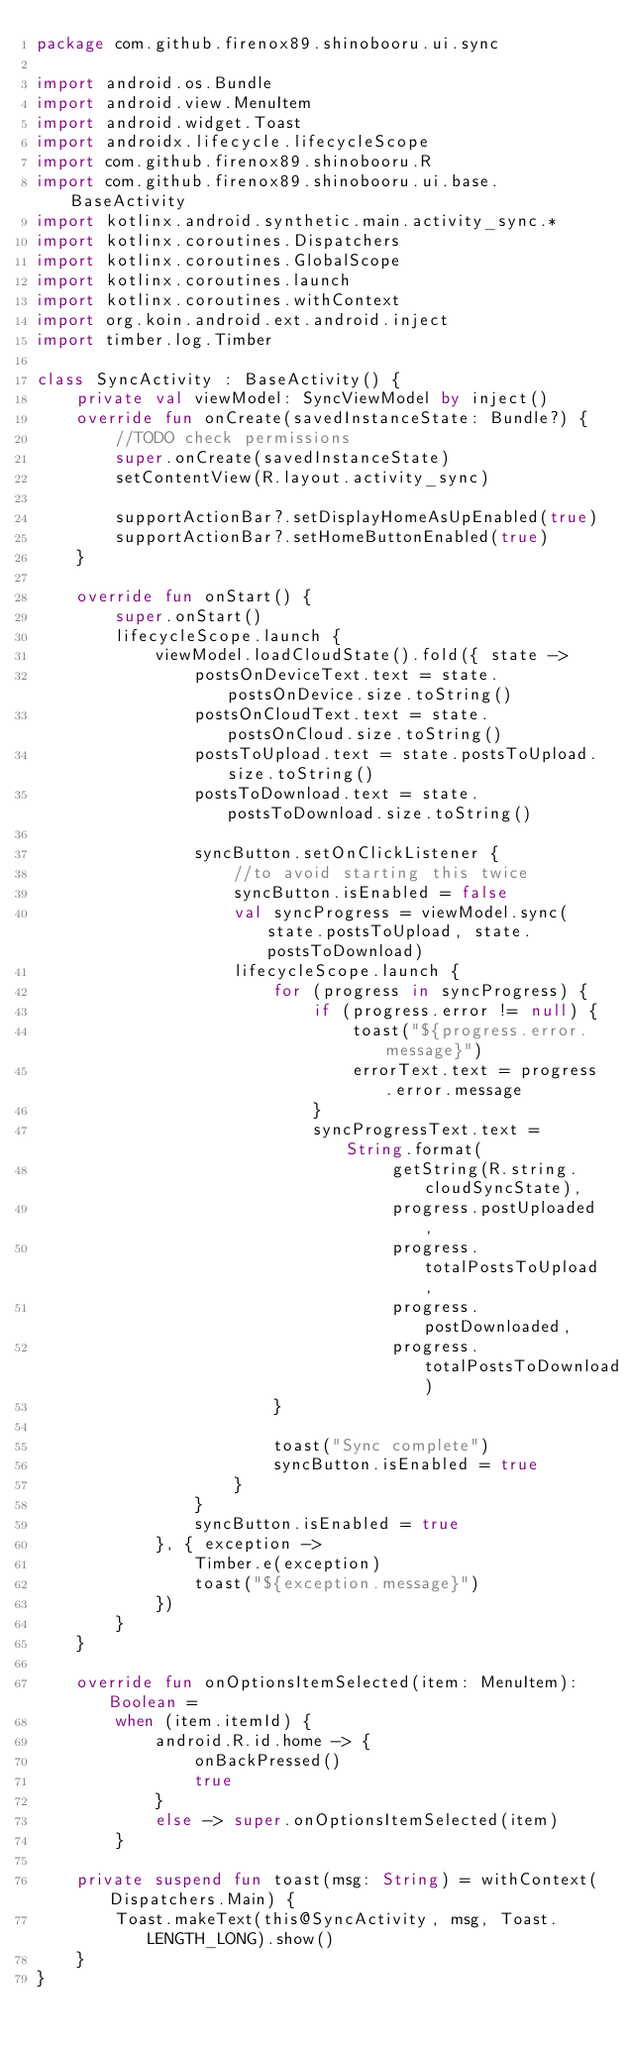<code> <loc_0><loc_0><loc_500><loc_500><_Kotlin_>package com.github.firenox89.shinobooru.ui.sync

import android.os.Bundle
import android.view.MenuItem
import android.widget.Toast
import androidx.lifecycle.lifecycleScope
import com.github.firenox89.shinobooru.R
import com.github.firenox89.shinobooru.ui.base.BaseActivity
import kotlinx.android.synthetic.main.activity_sync.*
import kotlinx.coroutines.Dispatchers
import kotlinx.coroutines.GlobalScope
import kotlinx.coroutines.launch
import kotlinx.coroutines.withContext
import org.koin.android.ext.android.inject
import timber.log.Timber

class SyncActivity : BaseActivity() {
    private val viewModel: SyncViewModel by inject()
    override fun onCreate(savedInstanceState: Bundle?) {
        //TODO check permissions
        super.onCreate(savedInstanceState)
        setContentView(R.layout.activity_sync)

        supportActionBar?.setDisplayHomeAsUpEnabled(true)
        supportActionBar?.setHomeButtonEnabled(true)
    }

    override fun onStart() {
        super.onStart()
        lifecycleScope.launch {
            viewModel.loadCloudState().fold({ state ->
                postsOnDeviceText.text = state.postsOnDevice.size.toString()
                postsOnCloudText.text = state.postsOnCloud.size.toString()
                postsToUpload.text = state.postsToUpload.size.toString()
                postsToDownload.text = state.postsToDownload.size.toString()

                syncButton.setOnClickListener {
                    //to avoid starting this twice
                    syncButton.isEnabled = false
                    val syncProgress = viewModel.sync(state.postsToUpload, state.postsToDownload)
                    lifecycleScope.launch {
                        for (progress in syncProgress) {
                            if (progress.error != null) {
                                toast("${progress.error.message}")
                                errorText.text = progress.error.message
                            }
                            syncProgressText.text = String.format(
                                    getString(R.string.cloudSyncState),
                                    progress.postUploaded,
                                    progress.totalPostsToUpload,
                                    progress.postDownloaded,
                                    progress.totalPostsToDownload)
                        }

                        toast("Sync complete")
                        syncButton.isEnabled = true
                    }
                }
                syncButton.isEnabled = true
            }, { exception ->
                Timber.e(exception)
                toast("${exception.message}")
            })
        }
    }

    override fun onOptionsItemSelected(item: MenuItem): Boolean =
        when (item.itemId) {
            android.R.id.home -> {
                onBackPressed()
                true
            }
            else -> super.onOptionsItemSelected(item)
        }

    private suspend fun toast(msg: String) = withContext(Dispatchers.Main) {
        Toast.makeText(this@SyncActivity, msg, Toast.LENGTH_LONG).show()
    }
}</code> 